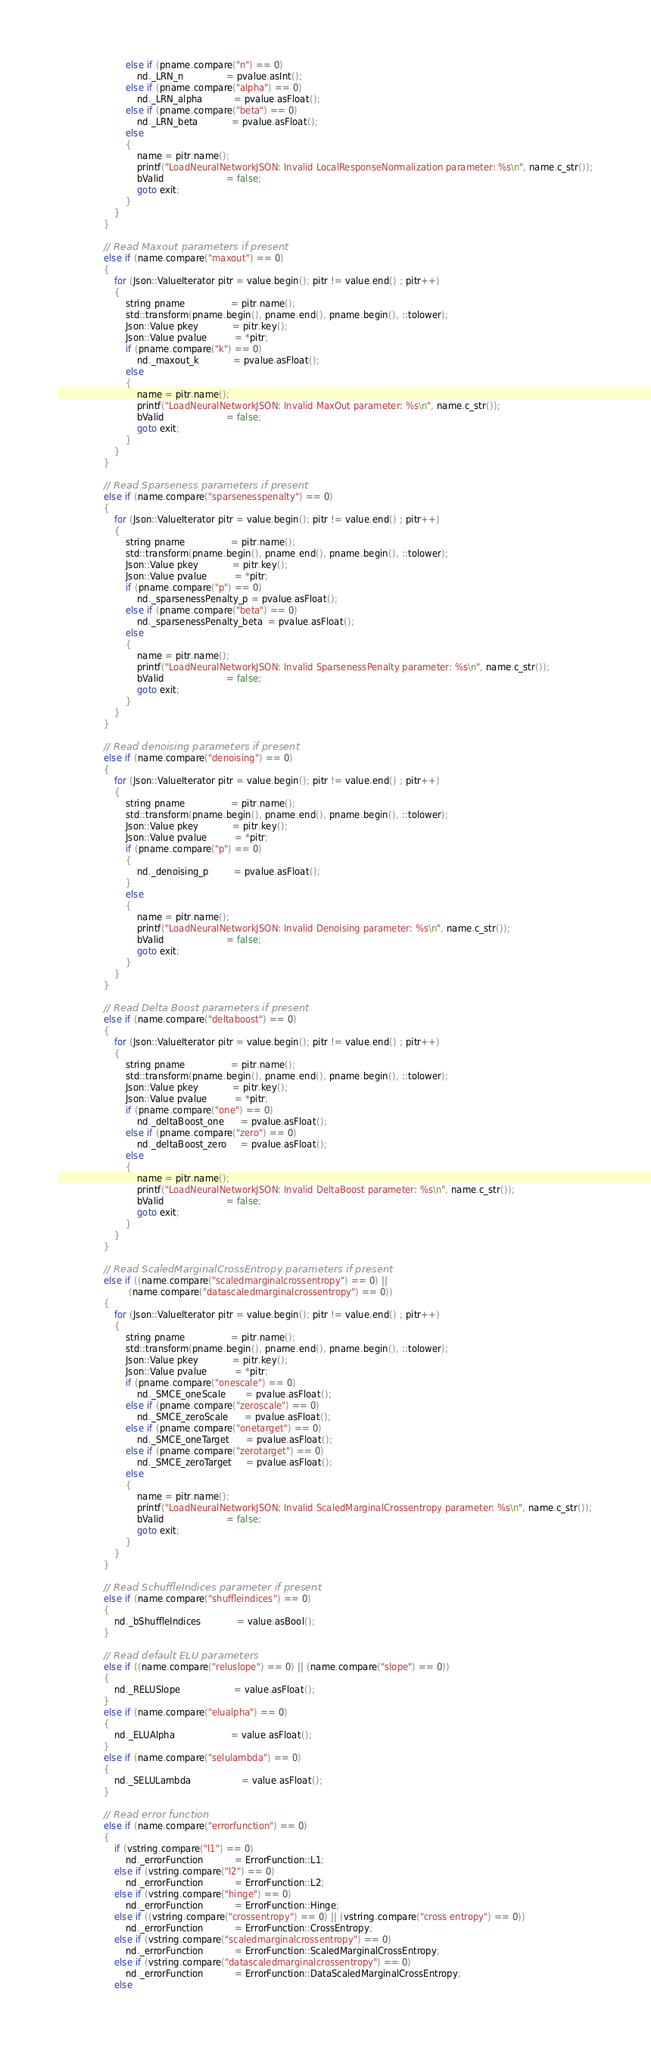Convert code to text. <code><loc_0><loc_0><loc_500><loc_500><_C++_>                        else if (pname.compare("n") == 0)
                            nd._LRN_n               = pvalue.asInt();
                        else if (pname.compare("alpha") == 0)
                            nd._LRN_alpha           = pvalue.asFloat();
                        else if (pname.compare("beta") == 0)
                            nd._LRN_beta            = pvalue.asFloat();
                        else
                        {
                            name = pitr.name();
                            printf("LoadNeuralNetworkJSON: Invalid LocalResponseNormalization parameter: %s\n", name.c_str());
                            bValid                      = false;
                            goto exit;
                        }
                    }
                }

                // Read Maxout parameters if present
                else if (name.compare("maxout") == 0)
                {
                    for (Json::ValueIterator pitr = value.begin(); pitr != value.end() ; pitr++)
                    {
                        string pname                = pitr.name();
                        std::transform(pname.begin(), pname.end(), pname.begin(), ::tolower);
                        Json::Value pkey            = pitr.key();
                        Json::Value pvalue          = *pitr;
                        if (pname.compare("k") == 0)
                            nd._maxout_k            = pvalue.asFloat();
                        else
                        {
                            name = pitr.name();
                            printf("LoadNeuralNetworkJSON: Invalid MaxOut parameter: %s\n", name.c_str());
                            bValid                      = false;
                            goto exit;
                        }
                    }
                }

                // Read Sparseness parameters if present
                else if (name.compare("sparsenesspenalty") == 0)
                {
                    for (Json::ValueIterator pitr = value.begin(); pitr != value.end() ; pitr++)
                    {
                        string pname                = pitr.name();
                        std::transform(pname.begin(), pname.end(), pname.begin(), ::tolower);
                        Json::Value pkey            = pitr.key();
                        Json::Value pvalue          = *pitr;
                        if (pname.compare("p") == 0)
                            nd._sparsenessPenalty_p = pvalue.asFloat();
                        else if (pname.compare("beta") == 0)
                            nd._sparsenessPenalty_beta  = pvalue.asFloat();
                        else
                        {
                            name = pitr.name();
                            printf("LoadNeuralNetworkJSON: Invalid SparsenessPenalty parameter: %s\n", name.c_str());
                            bValid                      = false;
                            goto exit;
                        }
                    }
                }

                // Read denoising parameters if present
                else if (name.compare("denoising") == 0)
                {
                    for (Json::ValueIterator pitr = value.begin(); pitr != value.end() ; pitr++)
                    {
                        string pname                = pitr.name();
                        std::transform(pname.begin(), pname.end(), pname.begin(), ::tolower);
                        Json::Value pkey            = pitr.key();
                        Json::Value pvalue          = *pitr;
                        if (pname.compare("p") == 0)
                        {
                            nd._denoising_p         = pvalue.asFloat();
                        }
                        else
                        {
                            name = pitr.name();
                            printf("LoadNeuralNetworkJSON: Invalid Denoising parameter: %s\n", name.c_str());
                            bValid                      = false;
                            goto exit;
                        }
                    }
                }

                // Read Delta Boost parameters if present
                else if (name.compare("deltaboost") == 0)
                {
                    for (Json::ValueIterator pitr = value.begin(); pitr != value.end() ; pitr++)
                    {
                        string pname                = pitr.name();
                        std::transform(pname.begin(), pname.end(), pname.begin(), ::tolower);
                        Json::Value pkey            = pitr.key();
                        Json::Value pvalue          = *pitr;
                        if (pname.compare("one") == 0)
                            nd._deltaBoost_one      = pvalue.asFloat();
                        else if (pname.compare("zero") == 0)
                            nd._deltaBoost_zero     = pvalue.asFloat();
                        else
                        {
                            name = pitr.name();
                            printf("LoadNeuralNetworkJSON: Invalid DeltaBoost parameter: %s\n", name.c_str());
                            bValid                      = false;
                            goto exit;
                        }
                    }
                }

                // Read ScaledMarginalCrossEntropy parameters if present
                else if ((name.compare("scaledmarginalcrossentropy") == 0) || 
                         (name.compare("datascaledmarginalcrossentropy") == 0))
                {
                    for (Json::ValueIterator pitr = value.begin(); pitr != value.end() ; pitr++)
                    {
                        string pname                = pitr.name();
                        std::transform(pname.begin(), pname.end(), pname.begin(), ::tolower);
                        Json::Value pkey            = pitr.key();
                        Json::Value pvalue          = *pitr;
                        if (pname.compare("onescale") == 0)
                            nd._SMCE_oneScale       = pvalue.asFloat();
                        else if (pname.compare("zeroscale") == 0)
                            nd._SMCE_zeroScale      = pvalue.asFloat();
                        else if (pname.compare("onetarget") == 0)
                            nd._SMCE_oneTarget      = pvalue.asFloat();
                        else if (pname.compare("zerotarget") == 0)
                            nd._SMCE_zeroTarget     = pvalue.asFloat();
                        else
                        {
                            name = pitr.name();
                            printf("LoadNeuralNetworkJSON: Invalid ScaledMarginalCrossentropy parameter: %s\n", name.c_str());
                            bValid                      = false;
                            goto exit;
                        }
                    }
                }

                // Read SchuffleIndices parameter if present
                else if (name.compare("shuffleindices") == 0)
                {
                    nd._bShuffleIndices             = value.asBool();
                }

                // Read default ELU parameters
                else if ((name.compare("reluslope") == 0) || (name.compare("slope") == 0))
                {
                    nd._RELUSlope                   = value.asFloat();
                }
                else if (name.compare("elualpha") == 0)
                {
                    nd._ELUAlpha                    = value.asFloat();                    
                }
                else if (name.compare("selulambda") == 0)
                {
                    nd._SELULambda                  = value.asFloat();
                }
                
                // Read error function
                else if (name.compare("errorfunction") == 0)
                {
                    if (vstring.compare("l1") == 0)
                        nd._errorFunction           = ErrorFunction::L1;
                    else if (vstring.compare("l2") == 0)
                        nd._errorFunction           = ErrorFunction::L2;
                    else if (vstring.compare("hinge") == 0)
                        nd._errorFunction           = ErrorFunction::Hinge;
                    else if ((vstring.compare("crossentropy") == 0) || (vstring.compare("cross entropy") == 0))
                        nd._errorFunction           = ErrorFunction::CrossEntropy;
                    else if (vstring.compare("scaledmarginalcrossentropy") == 0)
                        nd._errorFunction           = ErrorFunction::ScaledMarginalCrossEntropy;
                    else if (vstring.compare("datascaledmarginalcrossentropy") == 0)
                        nd._errorFunction           = ErrorFunction::DataScaledMarginalCrossEntropy;
                    else</code> 